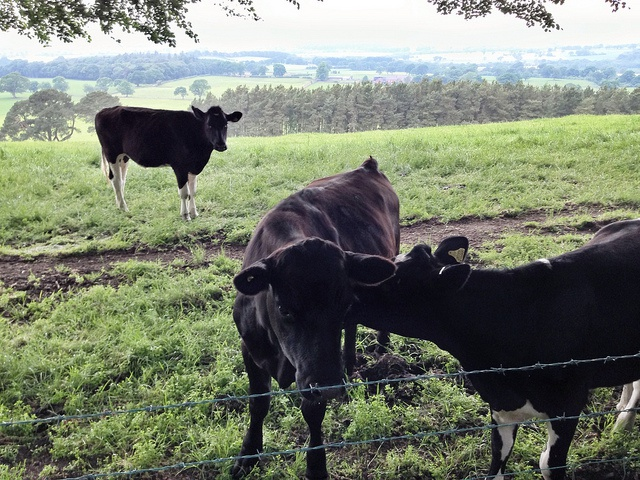Describe the objects in this image and their specific colors. I can see cow in lightgray, black, gray, darkgray, and olive tones, cow in lightgray, black, and gray tones, and cow in lightgray, black, gray, and darkgray tones in this image. 